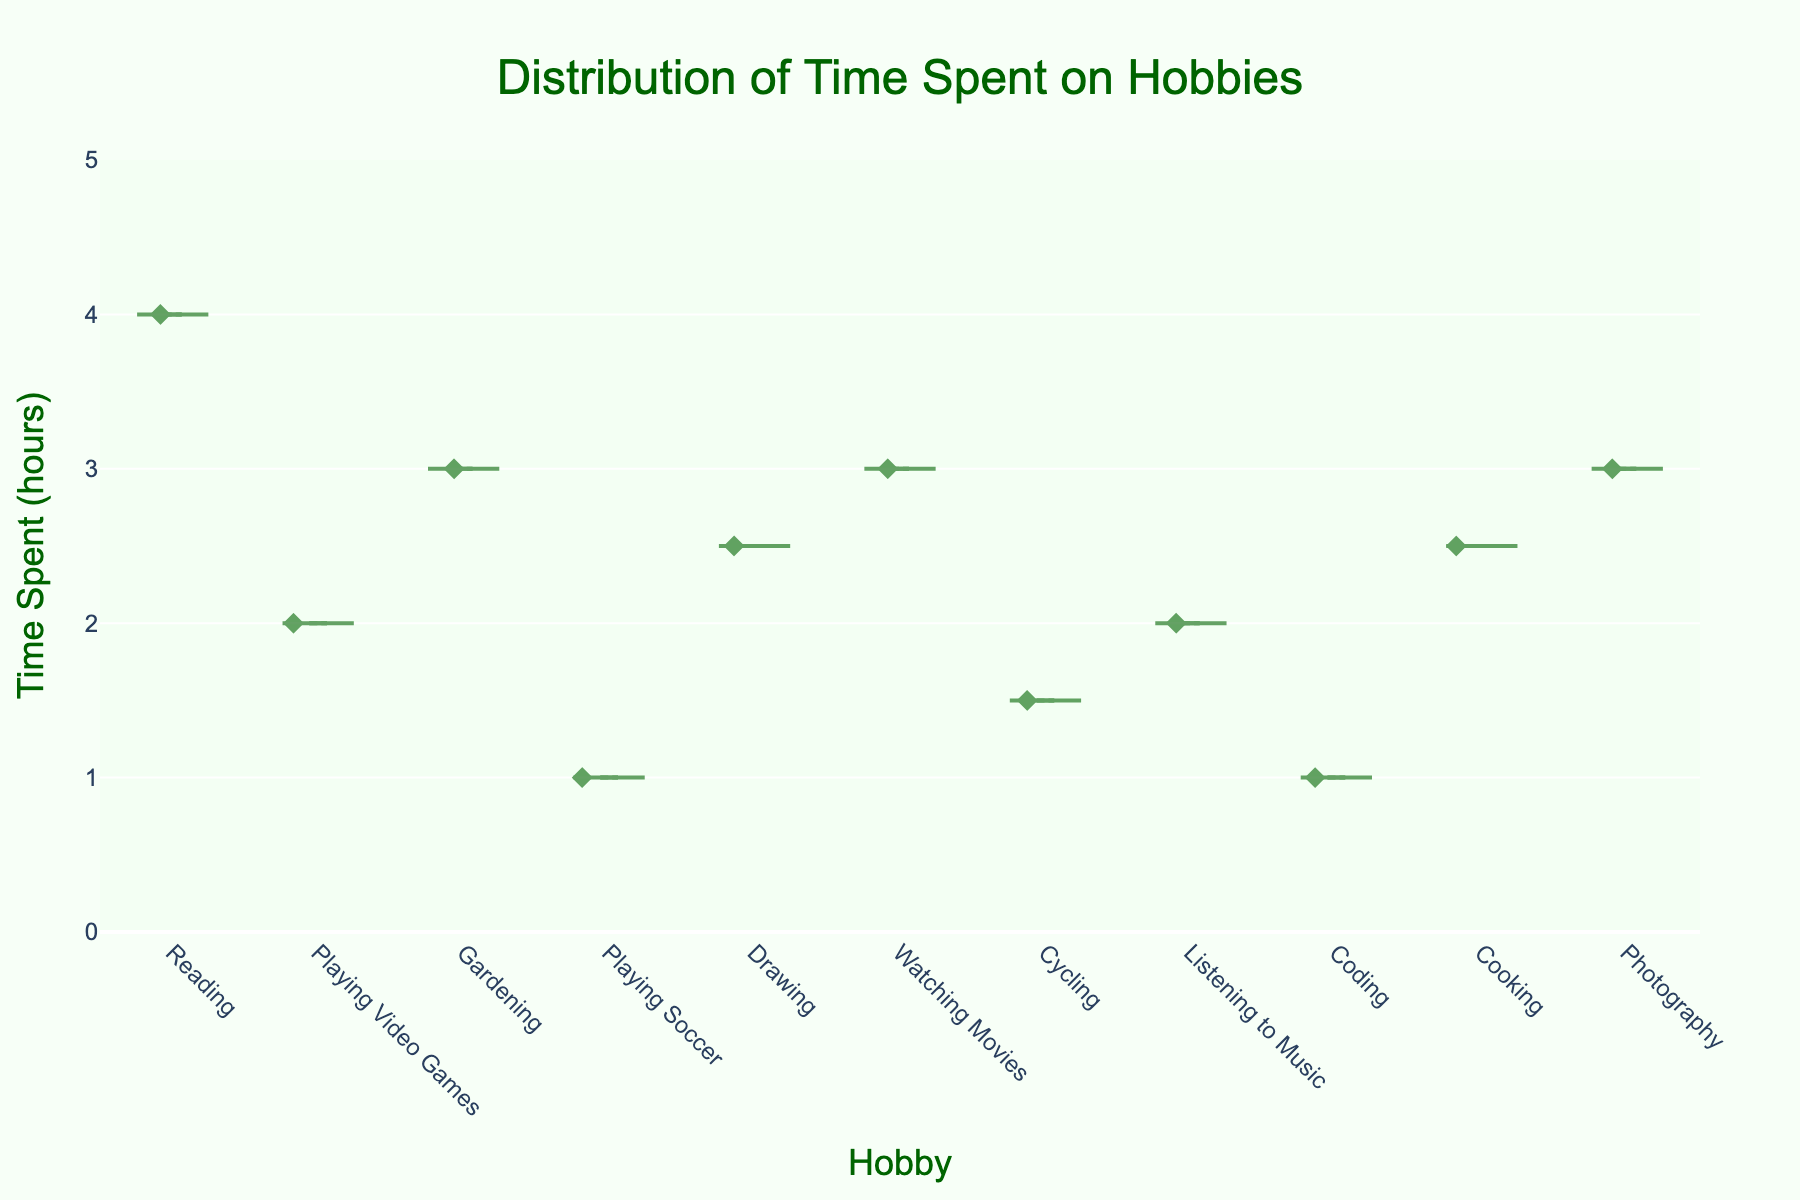What is the title of the figure? The title is usually placed at the top of the figure and is one of the first things to notice. By looking at the top center of the figure, you can see that the title is "Distribution of Time Spent on Hobbies".
Answer: Distribution of Time Spent on Hobbies What is the maximum time spent on any hobby? The y-axis represents the time spent in hours. By looking at the topmost point on the y-axis, the maximum value is 4 hours, which corresponds to Reading.
Answer: 4 hours Which hobby has the lowest average time spent? The meanline visible for each violin plot shows the average. "Playing Soccer" shows the lowest average time spent as indicated by its meanline.
Answer: Playing Soccer How many hobbies have a time spent of 3 hours? By looking at the figure, the points are plotted along the y-axis. Gardening, Watching Movies, and Photography have points at 3 hours. Counting these, we see there are three hobbies with 3 hours.
Answer: 3 hobbies Which hobbies take up more than 2 hours on average? By examining the meanlines, we can see that Reading, Gardening, Watching Movies, Drawing, Cooking, and Photography have averages above 2 hours.
Answer: 6 hobbies What is the color of the dots in the violin plot? The color of the dots or points in the violin plot is noticeable within each violin and they are dark green in color.
Answer: Dark green Is there a hobby where time spent is exactly 1 hour? Checking the points plotted within each violin reveals that Playing Soccer and Coding have points exactly at 1 hour.
Answer: Yes Which hobby has the widest spread of time spent values? The visual width of the violin indicates the spread of the data. Reading has the widest spread, covering the range up to 4 hours.
Answer: Reading Between Drawing and Watching Movies, which hobby has a higher average time spent? By comparing the meanlines, Drawing has a lower average compared to Watching Movies. Therefore, Watching Movies has a higher average time spent.
Answer: Watching Movies What is the range of the y-axis? The y-axis is labeled with values and spans from 0 to one value higher than the maximum data point, which is 4. Therefore, the range is from 0 to 5 hours.
Answer: 0 to 5 hours 